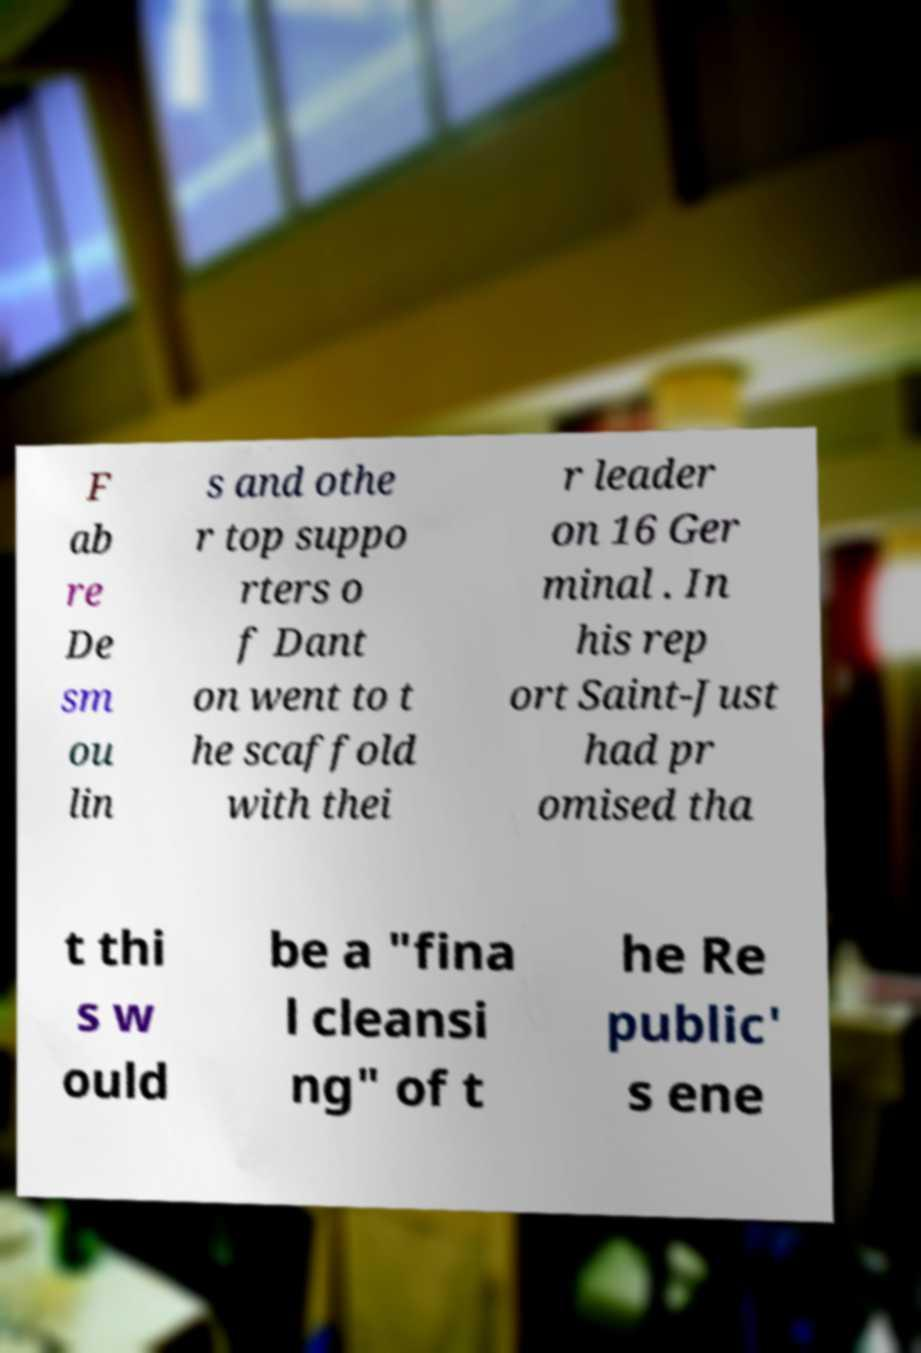Please identify and transcribe the text found in this image. F ab re De sm ou lin s and othe r top suppo rters o f Dant on went to t he scaffold with thei r leader on 16 Ger minal . In his rep ort Saint-Just had pr omised tha t thi s w ould be a "fina l cleansi ng" of t he Re public' s ene 